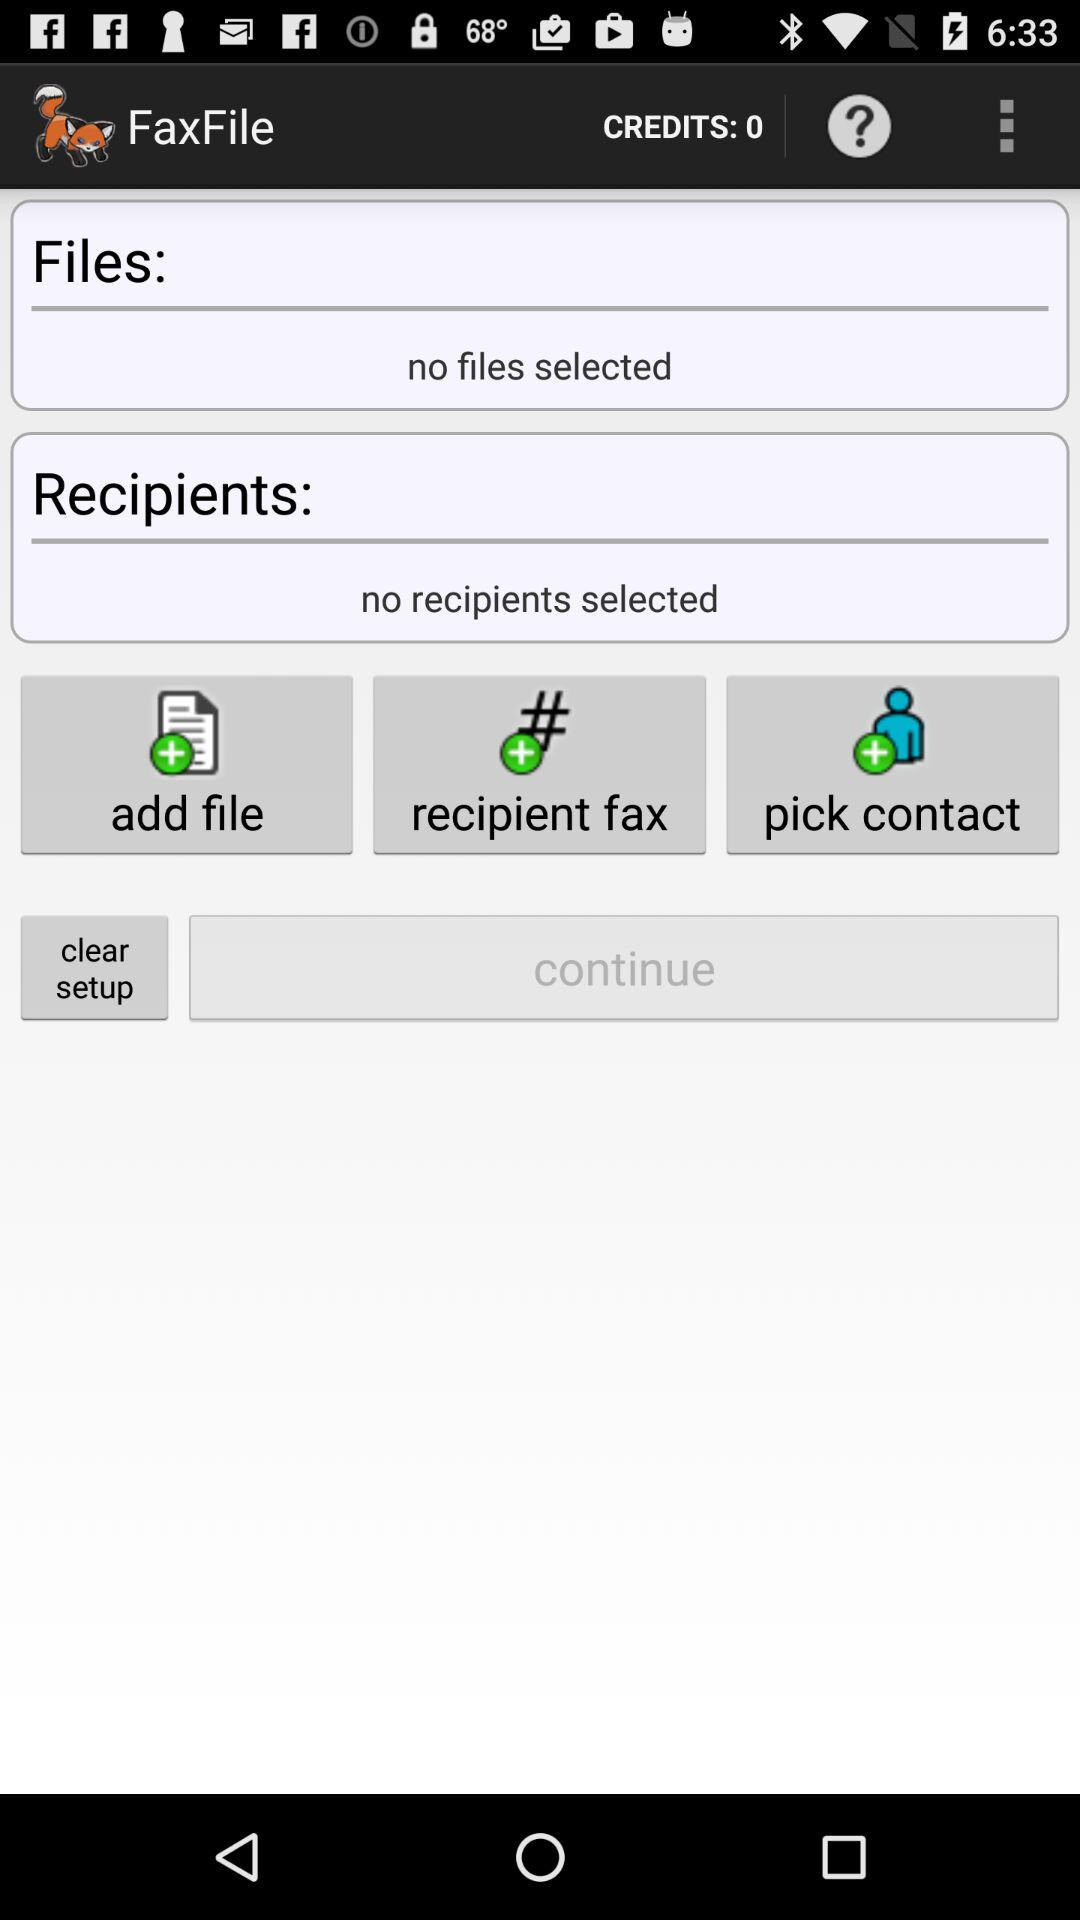How many files are selected?
Answer the question using a single word or phrase. 0 